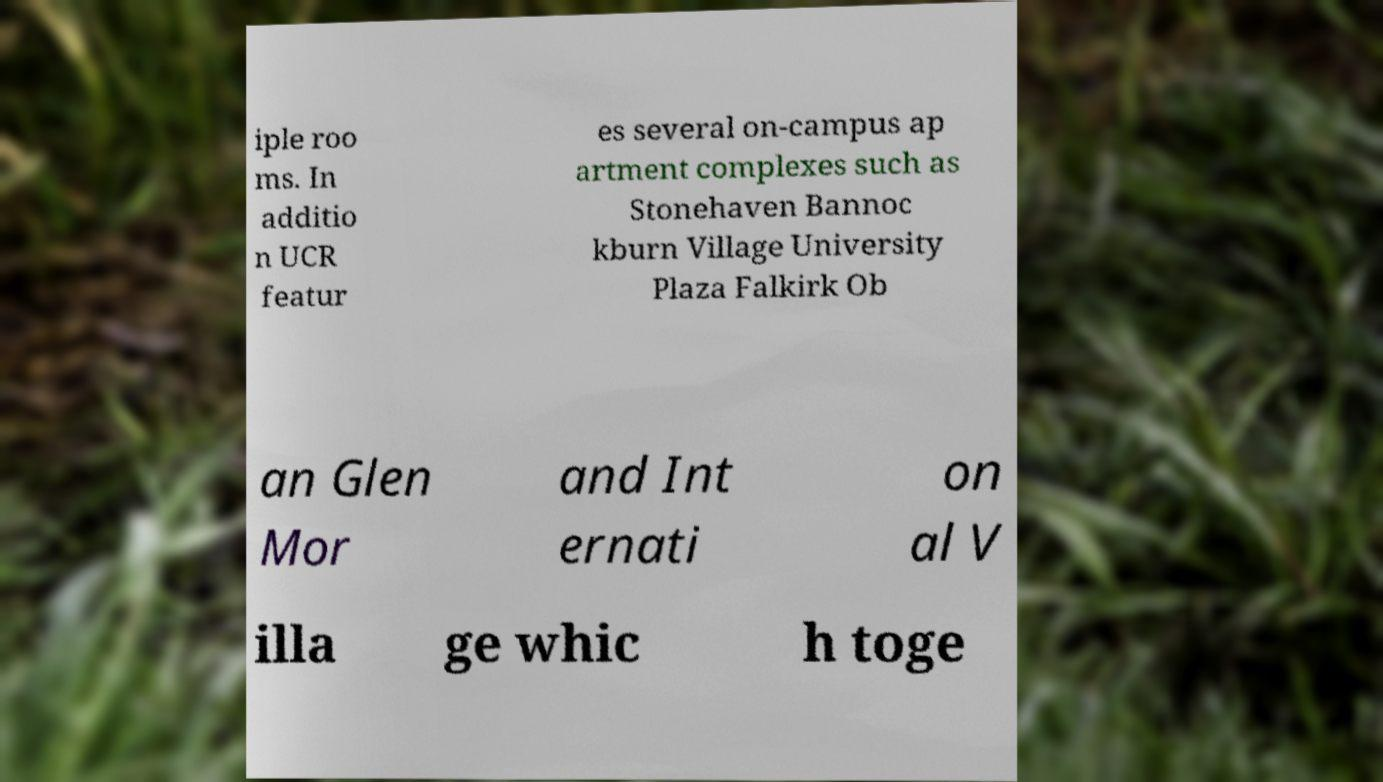Can you read and provide the text displayed in the image?This photo seems to have some interesting text. Can you extract and type it out for me? iple roo ms. In additio n UCR featur es several on-campus ap artment complexes such as Stonehaven Bannoc kburn Village University Plaza Falkirk Ob an Glen Mor and Int ernati on al V illa ge whic h toge 